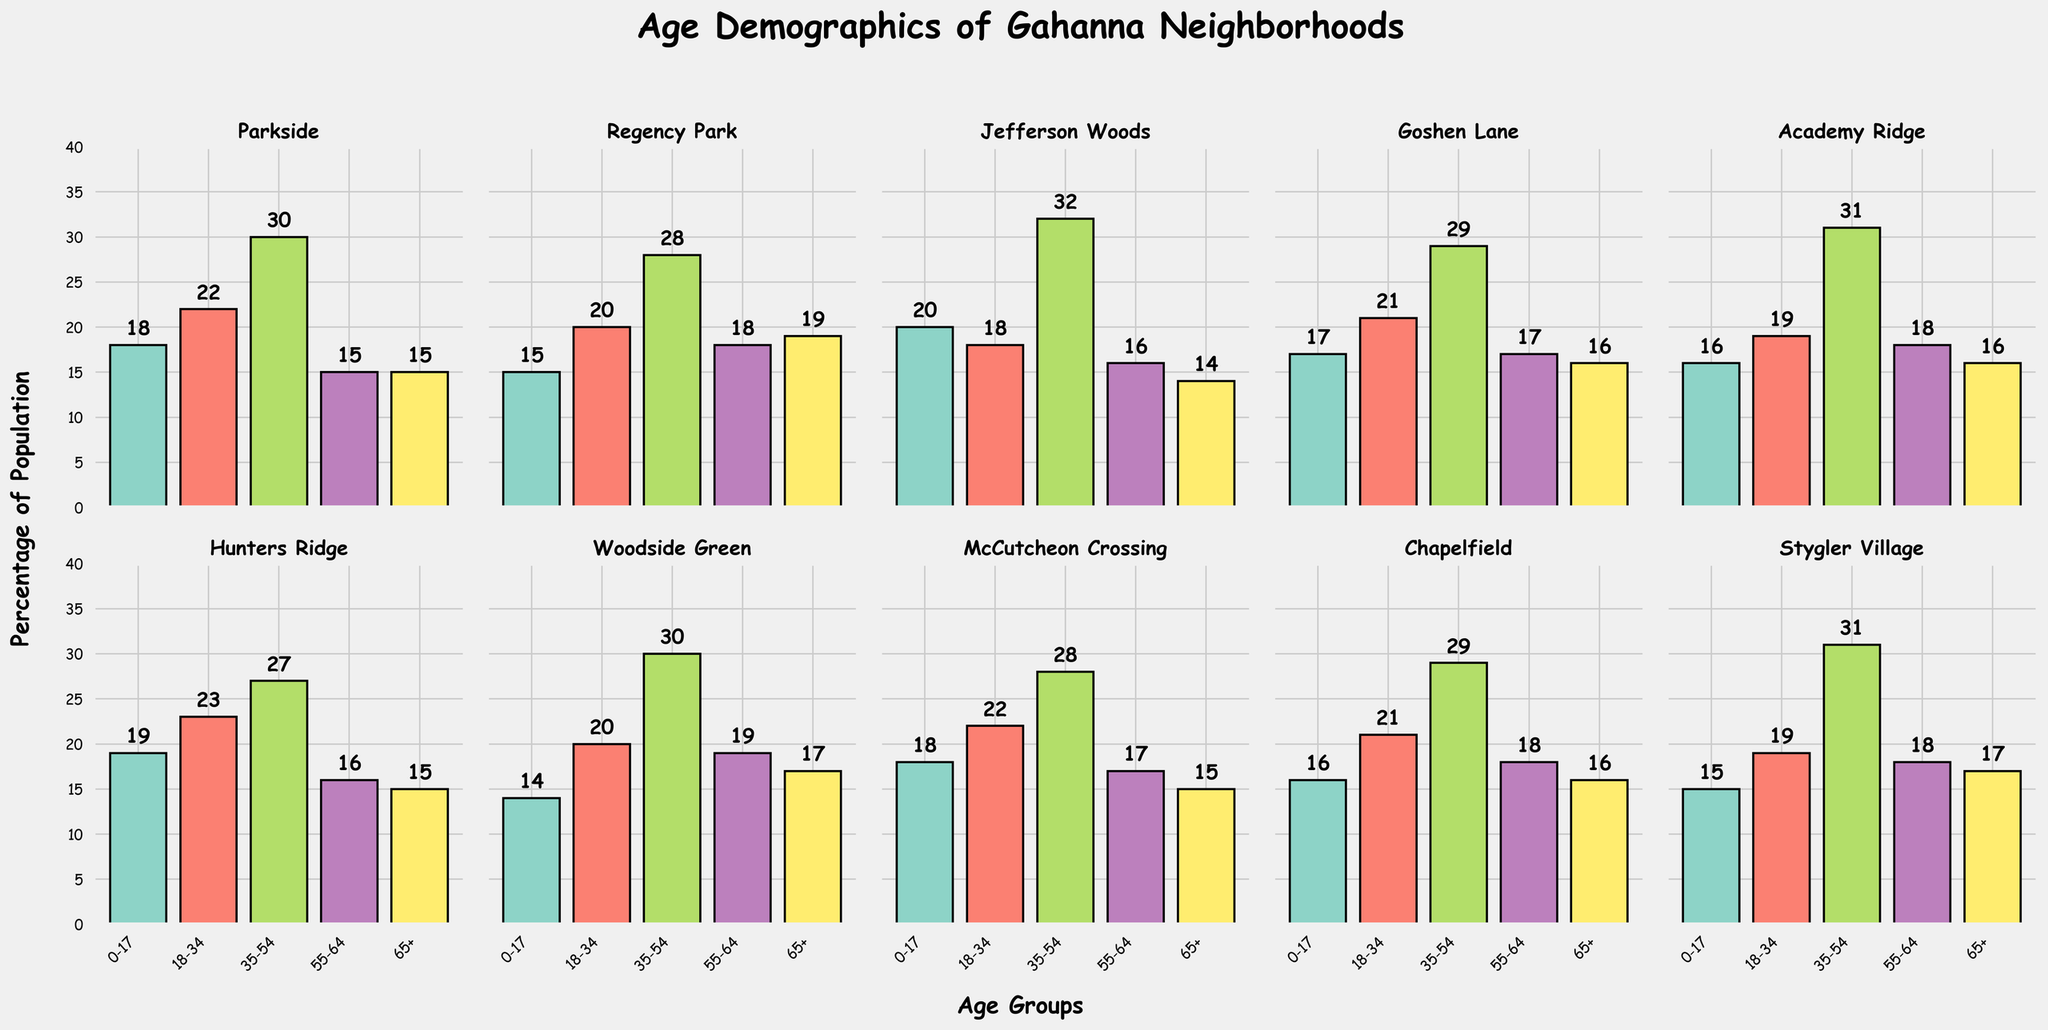What is the title of the chart? The title of the chart is located at the top center of the figure. It is clearly displayed and provides an overview of what the data represents.
Answer: Age Demographics of Gahanna Neighborhoods Which neighborhood has the highest number of residents aged 0-17? To determine this, look at the bar heights for the age group 0-17 across all neighborhoods and identify the tallest bar.
Answer: Hunters Ridge How does the number of residents aged 65+ in Parkside compare to those in Regency Park? Compare the heights of the bars for the 65+ age group in both Parkside and Regency Park to see which one is taller.
Answer: They are equal What is the sum of residents aged 18-34 in Parkside and Jefferson Woods? Add the values for the age group 18-34 from both Parkside and Jefferson Woods. Parkside has 22 and Jefferson Woods has 18. 22 + 18 = 40.
Answer: 40 Which neighborhood has the largest difference between the number of residents aged 0-17 and age 65+? Calculate the absolute difference for each neighborhood between the 0-17 and 65+ age groups and identify the largest.
Answer: Parkside What is the average number of residents aged 35-54 across all neighborhoods? Add the values for the 35-54 age group from all neighborhoods and divide by the number of neighborhoods (10). (30 + 28 + 32 + 29 + 31 + 27 + 30 + 28 + 29 + 31) / 10 = 295 / 10 = 29.5
Answer: 29.5 Which neighborhood has the highest number of residents aged 55-64? Identify the tallest bar in the 55-64 age group across all neighborhoods.
Answer: Woodside Green Are there any neighborhoods where the number of residents in the age group 0-17 is the same as in the age group 55-64? Check each neighborhood to see if the bars for the age group 0-17 and age group 55-64 are of equal height.
Answer: Parkside, McCutcheon Crossing What is the median value of residents aged 18-34 across all neighborhoods? Sort the values for the 18-34 age group and find the middle value. Sorted: 18, 19, 19, 20, 20, 21, 21, 22, 22, 23. The median of 10 values (average of 5th and 6th): (20 + 21) / 2 = 20.5.
Answer: 20.5 How many neighborhoods have fewer than 20 residents aged 18-34? Count the neighborhoods where the bar height for the 18-34 age group is less than 20. These neighborhoods are Jefferson Woods (18), Academy Ridge (19), Stygler Village (19).
Answer: 3 